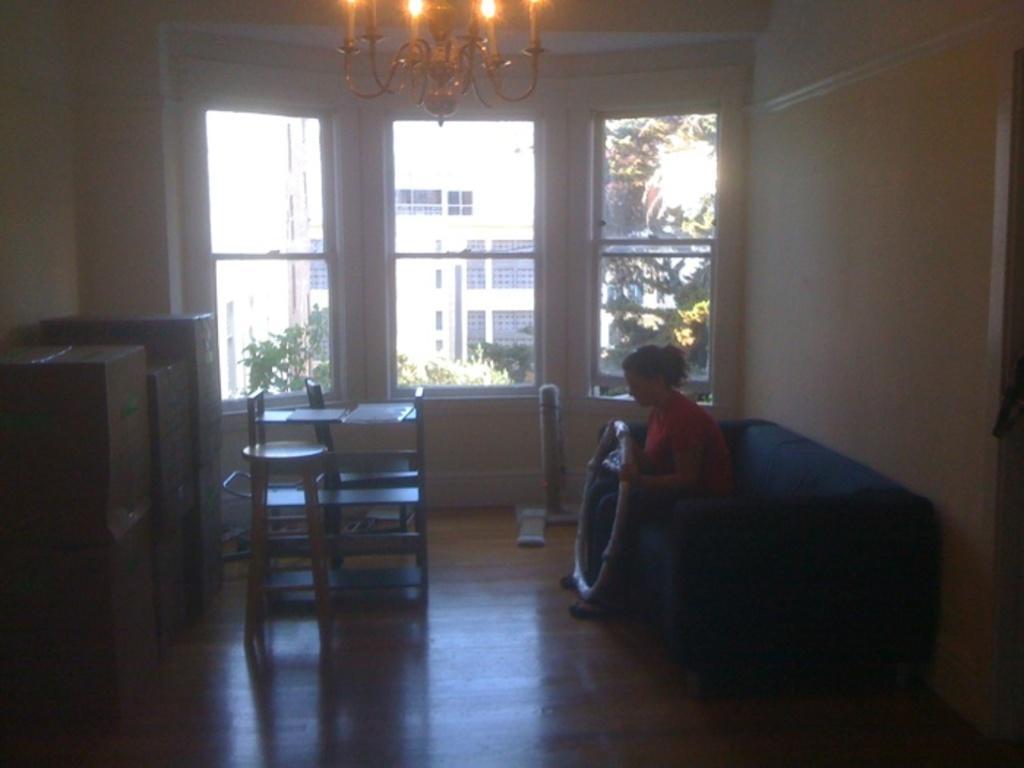Please provide a concise description of this image. In this image there is a woman sitting on the sofa by holding the ring. In front of her there are cardboard boxes kept one above the other on the floor. In the background there is a glass through which we can see the buildings and trees. In the middle there is a table on which there are papers and there are two chairs around it. At the top there is a chandelier. 